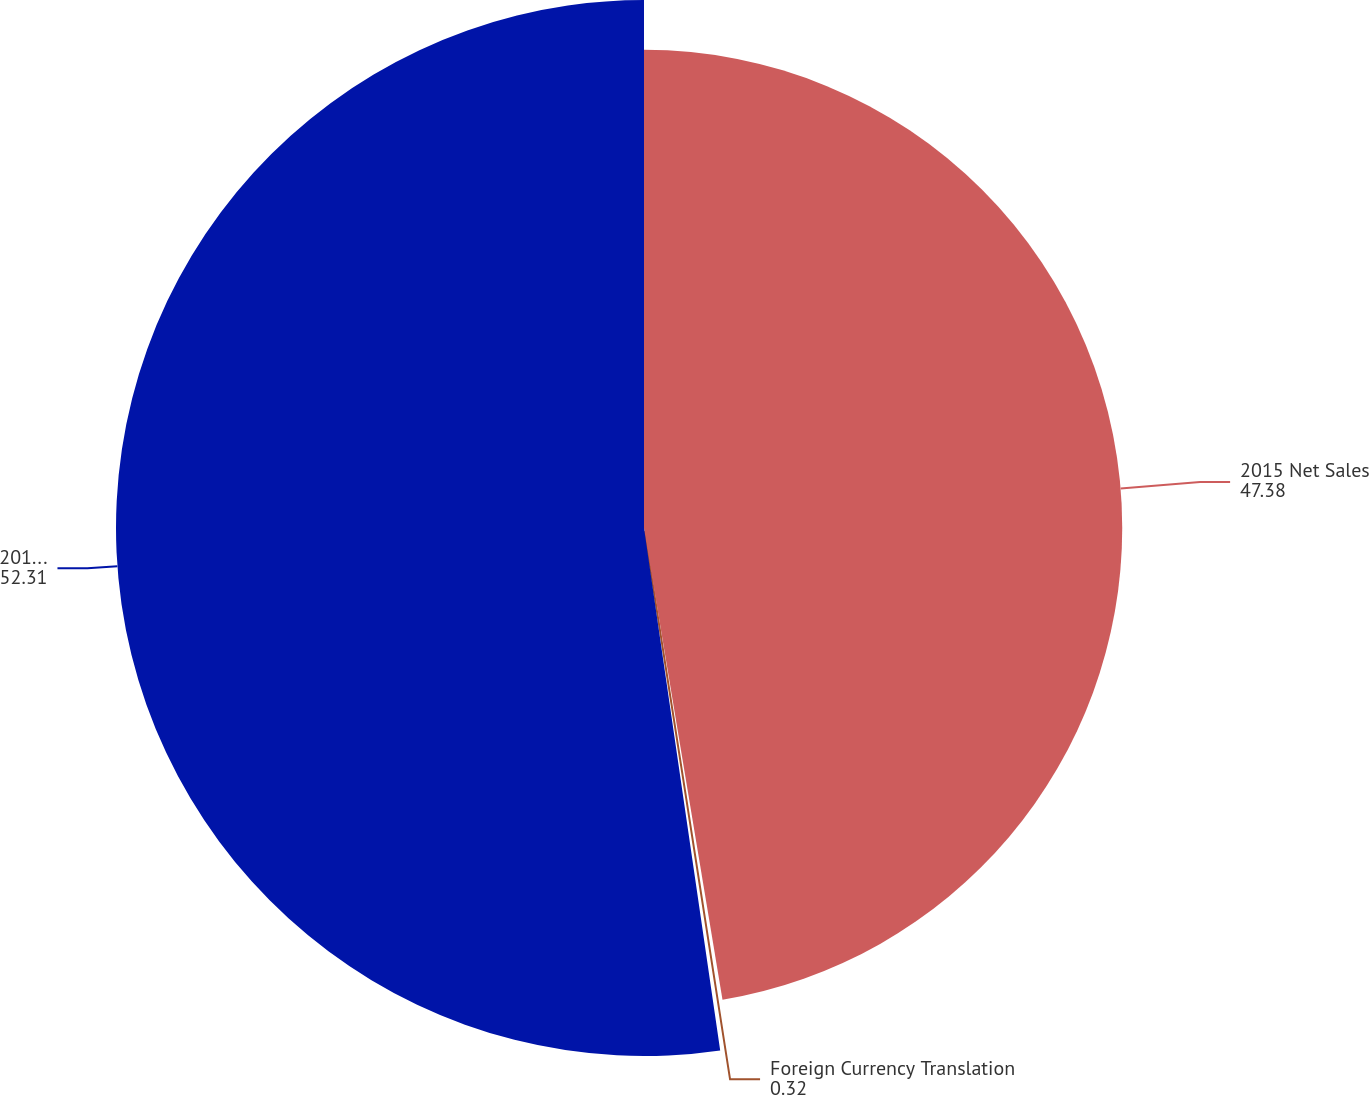Convert chart to OTSL. <chart><loc_0><loc_0><loc_500><loc_500><pie_chart><fcel>2015 Net Sales<fcel>Foreign Currency Translation<fcel>2016 Net Sales<nl><fcel>47.38%<fcel>0.32%<fcel>52.31%<nl></chart> 